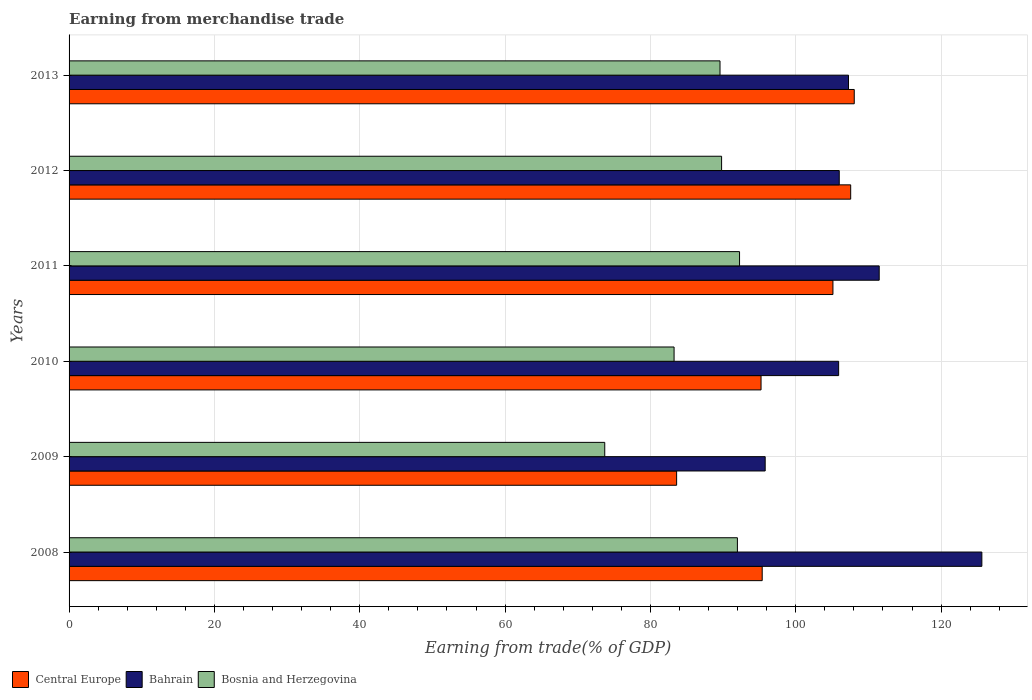How many groups of bars are there?
Offer a very short reply. 6. Are the number of bars per tick equal to the number of legend labels?
Your answer should be compact. Yes. How many bars are there on the 1st tick from the top?
Ensure brevity in your answer.  3. How many bars are there on the 4th tick from the bottom?
Offer a terse response. 3. In how many cases, is the number of bars for a given year not equal to the number of legend labels?
Your response must be concise. 0. What is the earnings from trade in Bahrain in 2011?
Your answer should be compact. 111.49. Across all years, what is the maximum earnings from trade in Bosnia and Herzegovina?
Provide a succinct answer. 92.27. Across all years, what is the minimum earnings from trade in Bosnia and Herzegovina?
Offer a very short reply. 73.72. In which year was the earnings from trade in Bosnia and Herzegovina maximum?
Your answer should be very brief. 2011. What is the total earnings from trade in Central Europe in the graph?
Offer a very short reply. 594.96. What is the difference between the earnings from trade in Bosnia and Herzegovina in 2009 and that in 2012?
Your response must be concise. -16.08. What is the difference between the earnings from trade in Central Europe in 2009 and the earnings from trade in Bosnia and Herzegovina in 2011?
Provide a short and direct response. -8.66. What is the average earnings from trade in Central Europe per year?
Your answer should be very brief. 99.16. In the year 2013, what is the difference between the earnings from trade in Bahrain and earnings from trade in Central Europe?
Keep it short and to the point. -0.79. In how many years, is the earnings from trade in Bosnia and Herzegovina greater than 104 %?
Offer a very short reply. 0. What is the ratio of the earnings from trade in Bahrain in 2009 to that in 2010?
Your response must be concise. 0.9. Is the earnings from trade in Central Europe in 2011 less than that in 2012?
Offer a very short reply. Yes. What is the difference between the highest and the second highest earnings from trade in Central Europe?
Ensure brevity in your answer.  0.49. What is the difference between the highest and the lowest earnings from trade in Central Europe?
Your answer should be compact. 24.44. In how many years, is the earnings from trade in Bahrain greater than the average earnings from trade in Bahrain taken over all years?
Ensure brevity in your answer.  2. What does the 3rd bar from the top in 2013 represents?
Keep it short and to the point. Central Europe. What does the 3rd bar from the bottom in 2010 represents?
Ensure brevity in your answer.  Bosnia and Herzegovina. Is it the case that in every year, the sum of the earnings from trade in Bosnia and Herzegovina and earnings from trade in Central Europe is greater than the earnings from trade in Bahrain?
Your answer should be compact. Yes. How many bars are there?
Provide a short and direct response. 18. What is the difference between two consecutive major ticks on the X-axis?
Provide a short and direct response. 20. Are the values on the major ticks of X-axis written in scientific E-notation?
Your response must be concise. No. Does the graph contain any zero values?
Your answer should be very brief. No. Does the graph contain grids?
Offer a terse response. Yes. How many legend labels are there?
Offer a terse response. 3. What is the title of the graph?
Give a very brief answer. Earning from merchandise trade. What is the label or title of the X-axis?
Make the answer very short. Earning from trade(% of GDP). What is the label or title of the Y-axis?
Offer a terse response. Years. What is the Earning from trade(% of GDP) of Central Europe in 2008?
Offer a very short reply. 95.39. What is the Earning from trade(% of GDP) in Bahrain in 2008?
Ensure brevity in your answer.  125.61. What is the Earning from trade(% of GDP) of Bosnia and Herzegovina in 2008?
Make the answer very short. 91.97. What is the Earning from trade(% of GDP) in Central Europe in 2009?
Offer a terse response. 83.61. What is the Earning from trade(% of GDP) of Bahrain in 2009?
Your answer should be very brief. 95.79. What is the Earning from trade(% of GDP) in Bosnia and Herzegovina in 2009?
Your response must be concise. 73.72. What is the Earning from trade(% of GDP) of Central Europe in 2010?
Keep it short and to the point. 95.23. What is the Earning from trade(% of GDP) in Bahrain in 2010?
Offer a terse response. 105.9. What is the Earning from trade(% of GDP) in Bosnia and Herzegovina in 2010?
Provide a short and direct response. 83.26. What is the Earning from trade(% of GDP) of Central Europe in 2011?
Give a very brief answer. 105.12. What is the Earning from trade(% of GDP) of Bahrain in 2011?
Your answer should be compact. 111.49. What is the Earning from trade(% of GDP) in Bosnia and Herzegovina in 2011?
Provide a succinct answer. 92.27. What is the Earning from trade(% of GDP) in Central Europe in 2012?
Your response must be concise. 107.56. What is the Earning from trade(% of GDP) of Bahrain in 2012?
Offer a very short reply. 105.99. What is the Earning from trade(% of GDP) in Bosnia and Herzegovina in 2012?
Ensure brevity in your answer.  89.8. What is the Earning from trade(% of GDP) in Central Europe in 2013?
Provide a short and direct response. 108.05. What is the Earning from trade(% of GDP) in Bahrain in 2013?
Offer a terse response. 107.26. What is the Earning from trade(% of GDP) in Bosnia and Herzegovina in 2013?
Provide a short and direct response. 89.58. Across all years, what is the maximum Earning from trade(% of GDP) of Central Europe?
Ensure brevity in your answer.  108.05. Across all years, what is the maximum Earning from trade(% of GDP) in Bahrain?
Your response must be concise. 125.61. Across all years, what is the maximum Earning from trade(% of GDP) in Bosnia and Herzegovina?
Your answer should be compact. 92.27. Across all years, what is the minimum Earning from trade(% of GDP) of Central Europe?
Provide a succinct answer. 83.61. Across all years, what is the minimum Earning from trade(% of GDP) in Bahrain?
Make the answer very short. 95.79. Across all years, what is the minimum Earning from trade(% of GDP) in Bosnia and Herzegovina?
Your response must be concise. 73.72. What is the total Earning from trade(% of GDP) in Central Europe in the graph?
Provide a short and direct response. 594.96. What is the total Earning from trade(% of GDP) of Bahrain in the graph?
Offer a very short reply. 652.05. What is the total Earning from trade(% of GDP) in Bosnia and Herzegovina in the graph?
Offer a very short reply. 520.59. What is the difference between the Earning from trade(% of GDP) in Central Europe in 2008 and that in 2009?
Ensure brevity in your answer.  11.78. What is the difference between the Earning from trade(% of GDP) in Bahrain in 2008 and that in 2009?
Give a very brief answer. 29.82. What is the difference between the Earning from trade(% of GDP) in Bosnia and Herzegovina in 2008 and that in 2009?
Provide a short and direct response. 18.25. What is the difference between the Earning from trade(% of GDP) in Central Europe in 2008 and that in 2010?
Offer a terse response. 0.16. What is the difference between the Earning from trade(% of GDP) in Bahrain in 2008 and that in 2010?
Offer a very short reply. 19.71. What is the difference between the Earning from trade(% of GDP) in Bosnia and Herzegovina in 2008 and that in 2010?
Provide a short and direct response. 8.71. What is the difference between the Earning from trade(% of GDP) in Central Europe in 2008 and that in 2011?
Provide a short and direct response. -9.73. What is the difference between the Earning from trade(% of GDP) of Bahrain in 2008 and that in 2011?
Provide a short and direct response. 14.13. What is the difference between the Earning from trade(% of GDP) of Bosnia and Herzegovina in 2008 and that in 2011?
Your answer should be very brief. -0.29. What is the difference between the Earning from trade(% of GDP) of Central Europe in 2008 and that in 2012?
Offer a very short reply. -12.18. What is the difference between the Earning from trade(% of GDP) in Bahrain in 2008 and that in 2012?
Provide a succinct answer. 19.62. What is the difference between the Earning from trade(% of GDP) of Bosnia and Herzegovina in 2008 and that in 2012?
Provide a succinct answer. 2.18. What is the difference between the Earning from trade(% of GDP) of Central Europe in 2008 and that in 2013?
Ensure brevity in your answer.  -12.67. What is the difference between the Earning from trade(% of GDP) of Bahrain in 2008 and that in 2013?
Keep it short and to the point. 18.35. What is the difference between the Earning from trade(% of GDP) of Bosnia and Herzegovina in 2008 and that in 2013?
Ensure brevity in your answer.  2.39. What is the difference between the Earning from trade(% of GDP) of Central Europe in 2009 and that in 2010?
Provide a succinct answer. -11.62. What is the difference between the Earning from trade(% of GDP) of Bahrain in 2009 and that in 2010?
Your answer should be very brief. -10.11. What is the difference between the Earning from trade(% of GDP) in Bosnia and Herzegovina in 2009 and that in 2010?
Ensure brevity in your answer.  -9.54. What is the difference between the Earning from trade(% of GDP) of Central Europe in 2009 and that in 2011?
Keep it short and to the point. -21.51. What is the difference between the Earning from trade(% of GDP) of Bahrain in 2009 and that in 2011?
Your answer should be very brief. -15.69. What is the difference between the Earning from trade(% of GDP) in Bosnia and Herzegovina in 2009 and that in 2011?
Offer a very short reply. -18.55. What is the difference between the Earning from trade(% of GDP) in Central Europe in 2009 and that in 2012?
Your response must be concise. -23.95. What is the difference between the Earning from trade(% of GDP) of Bahrain in 2009 and that in 2012?
Keep it short and to the point. -10.19. What is the difference between the Earning from trade(% of GDP) in Bosnia and Herzegovina in 2009 and that in 2012?
Keep it short and to the point. -16.08. What is the difference between the Earning from trade(% of GDP) of Central Europe in 2009 and that in 2013?
Ensure brevity in your answer.  -24.44. What is the difference between the Earning from trade(% of GDP) in Bahrain in 2009 and that in 2013?
Make the answer very short. -11.47. What is the difference between the Earning from trade(% of GDP) of Bosnia and Herzegovina in 2009 and that in 2013?
Provide a succinct answer. -15.86. What is the difference between the Earning from trade(% of GDP) in Central Europe in 2010 and that in 2011?
Give a very brief answer. -9.89. What is the difference between the Earning from trade(% of GDP) in Bahrain in 2010 and that in 2011?
Your answer should be compact. -5.58. What is the difference between the Earning from trade(% of GDP) in Bosnia and Herzegovina in 2010 and that in 2011?
Your answer should be compact. -9.01. What is the difference between the Earning from trade(% of GDP) of Central Europe in 2010 and that in 2012?
Offer a very short reply. -12.34. What is the difference between the Earning from trade(% of GDP) in Bahrain in 2010 and that in 2012?
Make the answer very short. -0.08. What is the difference between the Earning from trade(% of GDP) in Bosnia and Herzegovina in 2010 and that in 2012?
Your answer should be compact. -6.54. What is the difference between the Earning from trade(% of GDP) of Central Europe in 2010 and that in 2013?
Provide a succinct answer. -12.83. What is the difference between the Earning from trade(% of GDP) in Bahrain in 2010 and that in 2013?
Ensure brevity in your answer.  -1.36. What is the difference between the Earning from trade(% of GDP) of Bosnia and Herzegovina in 2010 and that in 2013?
Make the answer very short. -6.32. What is the difference between the Earning from trade(% of GDP) of Central Europe in 2011 and that in 2012?
Ensure brevity in your answer.  -2.44. What is the difference between the Earning from trade(% of GDP) of Bahrain in 2011 and that in 2012?
Offer a very short reply. 5.5. What is the difference between the Earning from trade(% of GDP) in Bosnia and Herzegovina in 2011 and that in 2012?
Give a very brief answer. 2.47. What is the difference between the Earning from trade(% of GDP) in Central Europe in 2011 and that in 2013?
Ensure brevity in your answer.  -2.93. What is the difference between the Earning from trade(% of GDP) in Bahrain in 2011 and that in 2013?
Your answer should be compact. 4.22. What is the difference between the Earning from trade(% of GDP) in Bosnia and Herzegovina in 2011 and that in 2013?
Give a very brief answer. 2.69. What is the difference between the Earning from trade(% of GDP) of Central Europe in 2012 and that in 2013?
Offer a very short reply. -0.49. What is the difference between the Earning from trade(% of GDP) in Bahrain in 2012 and that in 2013?
Provide a succinct answer. -1.27. What is the difference between the Earning from trade(% of GDP) in Bosnia and Herzegovina in 2012 and that in 2013?
Give a very brief answer. 0.22. What is the difference between the Earning from trade(% of GDP) in Central Europe in 2008 and the Earning from trade(% of GDP) in Bahrain in 2009?
Offer a terse response. -0.41. What is the difference between the Earning from trade(% of GDP) of Central Europe in 2008 and the Earning from trade(% of GDP) of Bosnia and Herzegovina in 2009?
Your answer should be compact. 21.67. What is the difference between the Earning from trade(% of GDP) of Bahrain in 2008 and the Earning from trade(% of GDP) of Bosnia and Herzegovina in 2009?
Provide a short and direct response. 51.89. What is the difference between the Earning from trade(% of GDP) in Central Europe in 2008 and the Earning from trade(% of GDP) in Bahrain in 2010?
Offer a very short reply. -10.52. What is the difference between the Earning from trade(% of GDP) in Central Europe in 2008 and the Earning from trade(% of GDP) in Bosnia and Herzegovina in 2010?
Provide a short and direct response. 12.13. What is the difference between the Earning from trade(% of GDP) in Bahrain in 2008 and the Earning from trade(% of GDP) in Bosnia and Herzegovina in 2010?
Your answer should be compact. 42.35. What is the difference between the Earning from trade(% of GDP) in Central Europe in 2008 and the Earning from trade(% of GDP) in Bahrain in 2011?
Ensure brevity in your answer.  -16.1. What is the difference between the Earning from trade(% of GDP) of Central Europe in 2008 and the Earning from trade(% of GDP) of Bosnia and Herzegovina in 2011?
Ensure brevity in your answer.  3.12. What is the difference between the Earning from trade(% of GDP) in Bahrain in 2008 and the Earning from trade(% of GDP) in Bosnia and Herzegovina in 2011?
Ensure brevity in your answer.  33.35. What is the difference between the Earning from trade(% of GDP) in Central Europe in 2008 and the Earning from trade(% of GDP) in Bahrain in 2012?
Your response must be concise. -10.6. What is the difference between the Earning from trade(% of GDP) in Central Europe in 2008 and the Earning from trade(% of GDP) in Bosnia and Herzegovina in 2012?
Offer a terse response. 5.59. What is the difference between the Earning from trade(% of GDP) of Bahrain in 2008 and the Earning from trade(% of GDP) of Bosnia and Herzegovina in 2012?
Provide a short and direct response. 35.82. What is the difference between the Earning from trade(% of GDP) of Central Europe in 2008 and the Earning from trade(% of GDP) of Bahrain in 2013?
Your answer should be very brief. -11.88. What is the difference between the Earning from trade(% of GDP) of Central Europe in 2008 and the Earning from trade(% of GDP) of Bosnia and Herzegovina in 2013?
Your response must be concise. 5.81. What is the difference between the Earning from trade(% of GDP) of Bahrain in 2008 and the Earning from trade(% of GDP) of Bosnia and Herzegovina in 2013?
Your answer should be very brief. 36.03. What is the difference between the Earning from trade(% of GDP) of Central Europe in 2009 and the Earning from trade(% of GDP) of Bahrain in 2010?
Keep it short and to the point. -22.29. What is the difference between the Earning from trade(% of GDP) of Central Europe in 2009 and the Earning from trade(% of GDP) of Bosnia and Herzegovina in 2010?
Make the answer very short. 0.35. What is the difference between the Earning from trade(% of GDP) in Bahrain in 2009 and the Earning from trade(% of GDP) in Bosnia and Herzegovina in 2010?
Provide a succinct answer. 12.54. What is the difference between the Earning from trade(% of GDP) of Central Europe in 2009 and the Earning from trade(% of GDP) of Bahrain in 2011?
Keep it short and to the point. -27.88. What is the difference between the Earning from trade(% of GDP) in Central Europe in 2009 and the Earning from trade(% of GDP) in Bosnia and Herzegovina in 2011?
Offer a very short reply. -8.66. What is the difference between the Earning from trade(% of GDP) in Bahrain in 2009 and the Earning from trade(% of GDP) in Bosnia and Herzegovina in 2011?
Your answer should be compact. 3.53. What is the difference between the Earning from trade(% of GDP) of Central Europe in 2009 and the Earning from trade(% of GDP) of Bahrain in 2012?
Make the answer very short. -22.38. What is the difference between the Earning from trade(% of GDP) in Central Europe in 2009 and the Earning from trade(% of GDP) in Bosnia and Herzegovina in 2012?
Provide a short and direct response. -6.19. What is the difference between the Earning from trade(% of GDP) in Bahrain in 2009 and the Earning from trade(% of GDP) in Bosnia and Herzegovina in 2012?
Provide a short and direct response. 6. What is the difference between the Earning from trade(% of GDP) in Central Europe in 2009 and the Earning from trade(% of GDP) in Bahrain in 2013?
Your answer should be very brief. -23.65. What is the difference between the Earning from trade(% of GDP) of Central Europe in 2009 and the Earning from trade(% of GDP) of Bosnia and Herzegovina in 2013?
Your answer should be very brief. -5.97. What is the difference between the Earning from trade(% of GDP) of Bahrain in 2009 and the Earning from trade(% of GDP) of Bosnia and Herzegovina in 2013?
Offer a very short reply. 6.22. What is the difference between the Earning from trade(% of GDP) in Central Europe in 2010 and the Earning from trade(% of GDP) in Bahrain in 2011?
Your answer should be very brief. -16.26. What is the difference between the Earning from trade(% of GDP) of Central Europe in 2010 and the Earning from trade(% of GDP) of Bosnia and Herzegovina in 2011?
Provide a short and direct response. 2.96. What is the difference between the Earning from trade(% of GDP) in Bahrain in 2010 and the Earning from trade(% of GDP) in Bosnia and Herzegovina in 2011?
Provide a short and direct response. 13.64. What is the difference between the Earning from trade(% of GDP) of Central Europe in 2010 and the Earning from trade(% of GDP) of Bahrain in 2012?
Keep it short and to the point. -10.76. What is the difference between the Earning from trade(% of GDP) in Central Europe in 2010 and the Earning from trade(% of GDP) in Bosnia and Herzegovina in 2012?
Keep it short and to the point. 5.43. What is the difference between the Earning from trade(% of GDP) of Bahrain in 2010 and the Earning from trade(% of GDP) of Bosnia and Herzegovina in 2012?
Make the answer very short. 16.11. What is the difference between the Earning from trade(% of GDP) in Central Europe in 2010 and the Earning from trade(% of GDP) in Bahrain in 2013?
Give a very brief answer. -12.04. What is the difference between the Earning from trade(% of GDP) of Central Europe in 2010 and the Earning from trade(% of GDP) of Bosnia and Herzegovina in 2013?
Your answer should be compact. 5.65. What is the difference between the Earning from trade(% of GDP) of Bahrain in 2010 and the Earning from trade(% of GDP) of Bosnia and Herzegovina in 2013?
Give a very brief answer. 16.32. What is the difference between the Earning from trade(% of GDP) in Central Europe in 2011 and the Earning from trade(% of GDP) in Bahrain in 2012?
Keep it short and to the point. -0.87. What is the difference between the Earning from trade(% of GDP) in Central Europe in 2011 and the Earning from trade(% of GDP) in Bosnia and Herzegovina in 2012?
Your answer should be compact. 15.32. What is the difference between the Earning from trade(% of GDP) of Bahrain in 2011 and the Earning from trade(% of GDP) of Bosnia and Herzegovina in 2012?
Offer a very short reply. 21.69. What is the difference between the Earning from trade(% of GDP) in Central Europe in 2011 and the Earning from trade(% of GDP) in Bahrain in 2013?
Offer a terse response. -2.14. What is the difference between the Earning from trade(% of GDP) in Central Europe in 2011 and the Earning from trade(% of GDP) in Bosnia and Herzegovina in 2013?
Your answer should be compact. 15.54. What is the difference between the Earning from trade(% of GDP) of Bahrain in 2011 and the Earning from trade(% of GDP) of Bosnia and Herzegovina in 2013?
Your answer should be very brief. 21.91. What is the difference between the Earning from trade(% of GDP) in Central Europe in 2012 and the Earning from trade(% of GDP) in Bahrain in 2013?
Offer a very short reply. 0.3. What is the difference between the Earning from trade(% of GDP) of Central Europe in 2012 and the Earning from trade(% of GDP) of Bosnia and Herzegovina in 2013?
Provide a succinct answer. 17.98. What is the difference between the Earning from trade(% of GDP) of Bahrain in 2012 and the Earning from trade(% of GDP) of Bosnia and Herzegovina in 2013?
Offer a terse response. 16.41. What is the average Earning from trade(% of GDP) of Central Europe per year?
Make the answer very short. 99.16. What is the average Earning from trade(% of GDP) in Bahrain per year?
Your response must be concise. 108.67. What is the average Earning from trade(% of GDP) in Bosnia and Herzegovina per year?
Your response must be concise. 86.77. In the year 2008, what is the difference between the Earning from trade(% of GDP) of Central Europe and Earning from trade(% of GDP) of Bahrain?
Your answer should be compact. -30.23. In the year 2008, what is the difference between the Earning from trade(% of GDP) of Central Europe and Earning from trade(% of GDP) of Bosnia and Herzegovina?
Make the answer very short. 3.41. In the year 2008, what is the difference between the Earning from trade(% of GDP) in Bahrain and Earning from trade(% of GDP) in Bosnia and Herzegovina?
Offer a very short reply. 33.64. In the year 2009, what is the difference between the Earning from trade(% of GDP) of Central Europe and Earning from trade(% of GDP) of Bahrain?
Offer a very short reply. -12.19. In the year 2009, what is the difference between the Earning from trade(% of GDP) of Central Europe and Earning from trade(% of GDP) of Bosnia and Herzegovina?
Keep it short and to the point. 9.89. In the year 2009, what is the difference between the Earning from trade(% of GDP) in Bahrain and Earning from trade(% of GDP) in Bosnia and Herzegovina?
Give a very brief answer. 22.08. In the year 2010, what is the difference between the Earning from trade(% of GDP) in Central Europe and Earning from trade(% of GDP) in Bahrain?
Your response must be concise. -10.68. In the year 2010, what is the difference between the Earning from trade(% of GDP) of Central Europe and Earning from trade(% of GDP) of Bosnia and Herzegovina?
Your response must be concise. 11.97. In the year 2010, what is the difference between the Earning from trade(% of GDP) of Bahrain and Earning from trade(% of GDP) of Bosnia and Herzegovina?
Your answer should be compact. 22.64. In the year 2011, what is the difference between the Earning from trade(% of GDP) of Central Europe and Earning from trade(% of GDP) of Bahrain?
Offer a terse response. -6.37. In the year 2011, what is the difference between the Earning from trade(% of GDP) of Central Europe and Earning from trade(% of GDP) of Bosnia and Herzegovina?
Offer a very short reply. 12.85. In the year 2011, what is the difference between the Earning from trade(% of GDP) of Bahrain and Earning from trade(% of GDP) of Bosnia and Herzegovina?
Your response must be concise. 19.22. In the year 2012, what is the difference between the Earning from trade(% of GDP) in Central Europe and Earning from trade(% of GDP) in Bahrain?
Provide a short and direct response. 1.57. In the year 2012, what is the difference between the Earning from trade(% of GDP) in Central Europe and Earning from trade(% of GDP) in Bosnia and Herzegovina?
Keep it short and to the point. 17.77. In the year 2012, what is the difference between the Earning from trade(% of GDP) in Bahrain and Earning from trade(% of GDP) in Bosnia and Herzegovina?
Ensure brevity in your answer.  16.19. In the year 2013, what is the difference between the Earning from trade(% of GDP) of Central Europe and Earning from trade(% of GDP) of Bahrain?
Make the answer very short. 0.79. In the year 2013, what is the difference between the Earning from trade(% of GDP) in Central Europe and Earning from trade(% of GDP) in Bosnia and Herzegovina?
Your answer should be compact. 18.47. In the year 2013, what is the difference between the Earning from trade(% of GDP) of Bahrain and Earning from trade(% of GDP) of Bosnia and Herzegovina?
Provide a succinct answer. 17.68. What is the ratio of the Earning from trade(% of GDP) in Central Europe in 2008 to that in 2009?
Provide a succinct answer. 1.14. What is the ratio of the Earning from trade(% of GDP) of Bahrain in 2008 to that in 2009?
Make the answer very short. 1.31. What is the ratio of the Earning from trade(% of GDP) of Bosnia and Herzegovina in 2008 to that in 2009?
Offer a very short reply. 1.25. What is the ratio of the Earning from trade(% of GDP) in Central Europe in 2008 to that in 2010?
Ensure brevity in your answer.  1. What is the ratio of the Earning from trade(% of GDP) of Bahrain in 2008 to that in 2010?
Give a very brief answer. 1.19. What is the ratio of the Earning from trade(% of GDP) of Bosnia and Herzegovina in 2008 to that in 2010?
Give a very brief answer. 1.1. What is the ratio of the Earning from trade(% of GDP) in Central Europe in 2008 to that in 2011?
Offer a very short reply. 0.91. What is the ratio of the Earning from trade(% of GDP) of Bahrain in 2008 to that in 2011?
Provide a short and direct response. 1.13. What is the ratio of the Earning from trade(% of GDP) in Central Europe in 2008 to that in 2012?
Offer a very short reply. 0.89. What is the ratio of the Earning from trade(% of GDP) in Bahrain in 2008 to that in 2012?
Your answer should be very brief. 1.19. What is the ratio of the Earning from trade(% of GDP) in Bosnia and Herzegovina in 2008 to that in 2012?
Provide a succinct answer. 1.02. What is the ratio of the Earning from trade(% of GDP) in Central Europe in 2008 to that in 2013?
Give a very brief answer. 0.88. What is the ratio of the Earning from trade(% of GDP) of Bahrain in 2008 to that in 2013?
Your answer should be compact. 1.17. What is the ratio of the Earning from trade(% of GDP) of Bosnia and Herzegovina in 2008 to that in 2013?
Make the answer very short. 1.03. What is the ratio of the Earning from trade(% of GDP) of Central Europe in 2009 to that in 2010?
Offer a very short reply. 0.88. What is the ratio of the Earning from trade(% of GDP) in Bahrain in 2009 to that in 2010?
Offer a very short reply. 0.9. What is the ratio of the Earning from trade(% of GDP) in Bosnia and Herzegovina in 2009 to that in 2010?
Give a very brief answer. 0.89. What is the ratio of the Earning from trade(% of GDP) of Central Europe in 2009 to that in 2011?
Offer a very short reply. 0.8. What is the ratio of the Earning from trade(% of GDP) of Bahrain in 2009 to that in 2011?
Keep it short and to the point. 0.86. What is the ratio of the Earning from trade(% of GDP) of Bosnia and Herzegovina in 2009 to that in 2011?
Your answer should be compact. 0.8. What is the ratio of the Earning from trade(% of GDP) in Central Europe in 2009 to that in 2012?
Make the answer very short. 0.78. What is the ratio of the Earning from trade(% of GDP) in Bahrain in 2009 to that in 2012?
Your answer should be very brief. 0.9. What is the ratio of the Earning from trade(% of GDP) in Bosnia and Herzegovina in 2009 to that in 2012?
Give a very brief answer. 0.82. What is the ratio of the Earning from trade(% of GDP) of Central Europe in 2009 to that in 2013?
Your answer should be compact. 0.77. What is the ratio of the Earning from trade(% of GDP) in Bahrain in 2009 to that in 2013?
Ensure brevity in your answer.  0.89. What is the ratio of the Earning from trade(% of GDP) of Bosnia and Herzegovina in 2009 to that in 2013?
Your answer should be very brief. 0.82. What is the ratio of the Earning from trade(% of GDP) in Central Europe in 2010 to that in 2011?
Offer a very short reply. 0.91. What is the ratio of the Earning from trade(% of GDP) in Bahrain in 2010 to that in 2011?
Provide a short and direct response. 0.95. What is the ratio of the Earning from trade(% of GDP) in Bosnia and Herzegovina in 2010 to that in 2011?
Make the answer very short. 0.9. What is the ratio of the Earning from trade(% of GDP) in Central Europe in 2010 to that in 2012?
Your response must be concise. 0.89. What is the ratio of the Earning from trade(% of GDP) in Bosnia and Herzegovina in 2010 to that in 2012?
Provide a short and direct response. 0.93. What is the ratio of the Earning from trade(% of GDP) in Central Europe in 2010 to that in 2013?
Give a very brief answer. 0.88. What is the ratio of the Earning from trade(% of GDP) of Bahrain in 2010 to that in 2013?
Keep it short and to the point. 0.99. What is the ratio of the Earning from trade(% of GDP) in Bosnia and Herzegovina in 2010 to that in 2013?
Keep it short and to the point. 0.93. What is the ratio of the Earning from trade(% of GDP) of Central Europe in 2011 to that in 2012?
Keep it short and to the point. 0.98. What is the ratio of the Earning from trade(% of GDP) in Bahrain in 2011 to that in 2012?
Give a very brief answer. 1.05. What is the ratio of the Earning from trade(% of GDP) in Bosnia and Herzegovina in 2011 to that in 2012?
Your answer should be compact. 1.03. What is the ratio of the Earning from trade(% of GDP) in Central Europe in 2011 to that in 2013?
Provide a succinct answer. 0.97. What is the ratio of the Earning from trade(% of GDP) in Bahrain in 2011 to that in 2013?
Keep it short and to the point. 1.04. What is the ratio of the Earning from trade(% of GDP) in Central Europe in 2012 to that in 2013?
Ensure brevity in your answer.  1. What is the ratio of the Earning from trade(% of GDP) in Bahrain in 2012 to that in 2013?
Give a very brief answer. 0.99. What is the difference between the highest and the second highest Earning from trade(% of GDP) of Central Europe?
Your answer should be very brief. 0.49. What is the difference between the highest and the second highest Earning from trade(% of GDP) of Bahrain?
Provide a succinct answer. 14.13. What is the difference between the highest and the second highest Earning from trade(% of GDP) of Bosnia and Herzegovina?
Your answer should be very brief. 0.29. What is the difference between the highest and the lowest Earning from trade(% of GDP) in Central Europe?
Your answer should be very brief. 24.44. What is the difference between the highest and the lowest Earning from trade(% of GDP) of Bahrain?
Keep it short and to the point. 29.82. What is the difference between the highest and the lowest Earning from trade(% of GDP) in Bosnia and Herzegovina?
Provide a short and direct response. 18.55. 